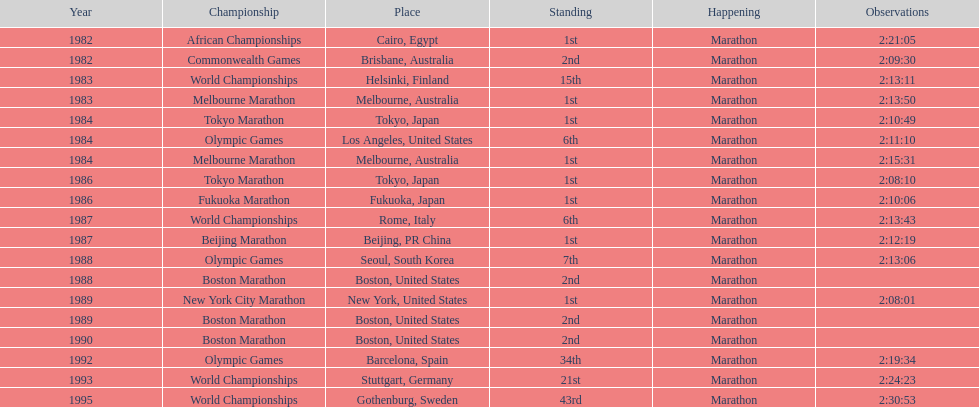What are the total number of times the position of 1st place was earned? 8. 